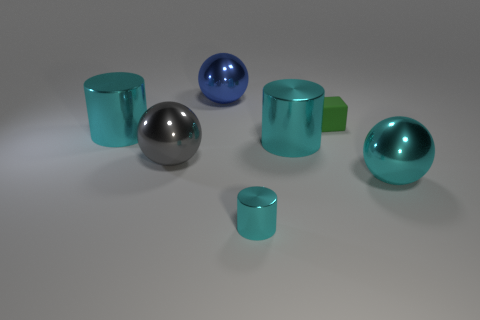Add 2 cyan shiny blocks. How many objects exist? 9 Subtract all cubes. How many objects are left? 6 Subtract 0 brown cubes. How many objects are left? 7 Subtract all shiny spheres. Subtract all big metallic balls. How many objects are left? 1 Add 7 cyan shiny balls. How many cyan shiny balls are left? 8 Add 6 small metal things. How many small metal things exist? 7 